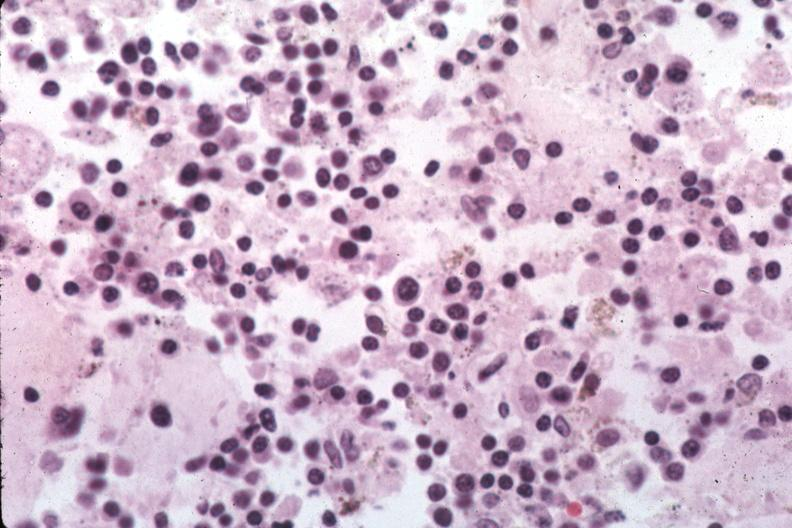re hyalin mass in pituitary which is amyloid there are several slides from this case in this file 23 yowf amyloid limited to brain easily evident?
Answer the question using a single word or phrase. No 